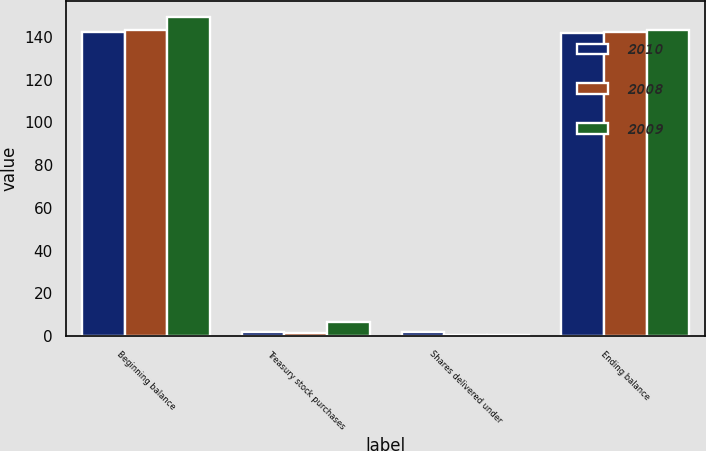<chart> <loc_0><loc_0><loc_500><loc_500><stacked_bar_chart><ecel><fcel>Beginning balance<fcel>Treasury stock purchases<fcel>Shares delivered under<fcel>Ending balance<nl><fcel>2010<fcel>142.1<fcel>2.2<fcel>1.8<fcel>141.7<nl><fcel>2008<fcel>143.2<fcel>1.7<fcel>0.6<fcel>142.1<nl><fcel>2009<fcel>149.4<fcel>6.7<fcel>0.5<fcel>143.2<nl></chart> 